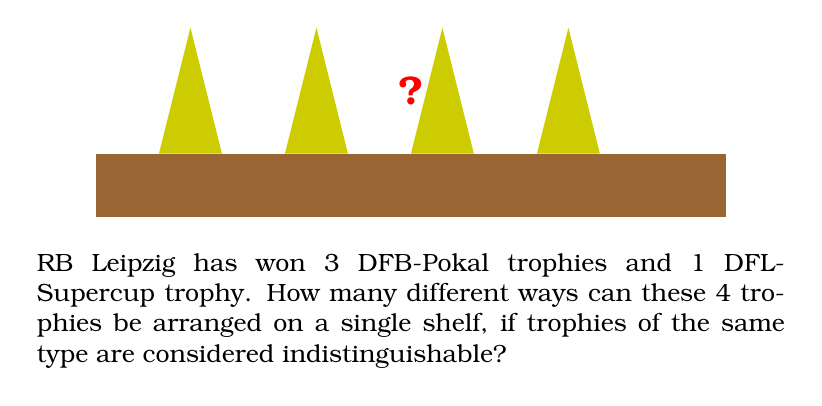Can you solve this math problem? Let's approach this step-by-step:

1) We have 4 trophies in total: 3 DFB-Pokal trophies (which are indistinguishable from each other) and 1 DFL-Supercup trophy.

2) This is a classic problem of permutation with repetition.

3) The formula for permutations with repetition is:

   $$\frac{n!}{n_1! \cdot n_2! \cdot ... \cdot n_k!}$$

   Where:
   - $n$ is the total number of items
   - $n_1, n_2, ..., n_k$ are the numbers of each type of item

4) In our case:
   - $n = 4$ (total trophies)
   - $n_1 = 3$ (DFB-Pokal trophies)
   - $n_2 = 1$ (DFL-Supercup trophy)

5) Plugging these numbers into our formula:

   $$\frac{4!}{3! \cdot 1!}$$

6) Let's calculate this:
   
   $$\frac{4 \cdot 3 \cdot 2 \cdot 1}{(3 \cdot 2 \cdot 1) \cdot 1} = \frac{24}{6} = 4$$

Therefore, there are 4 different ways to arrange the trophies.
Answer: 4 